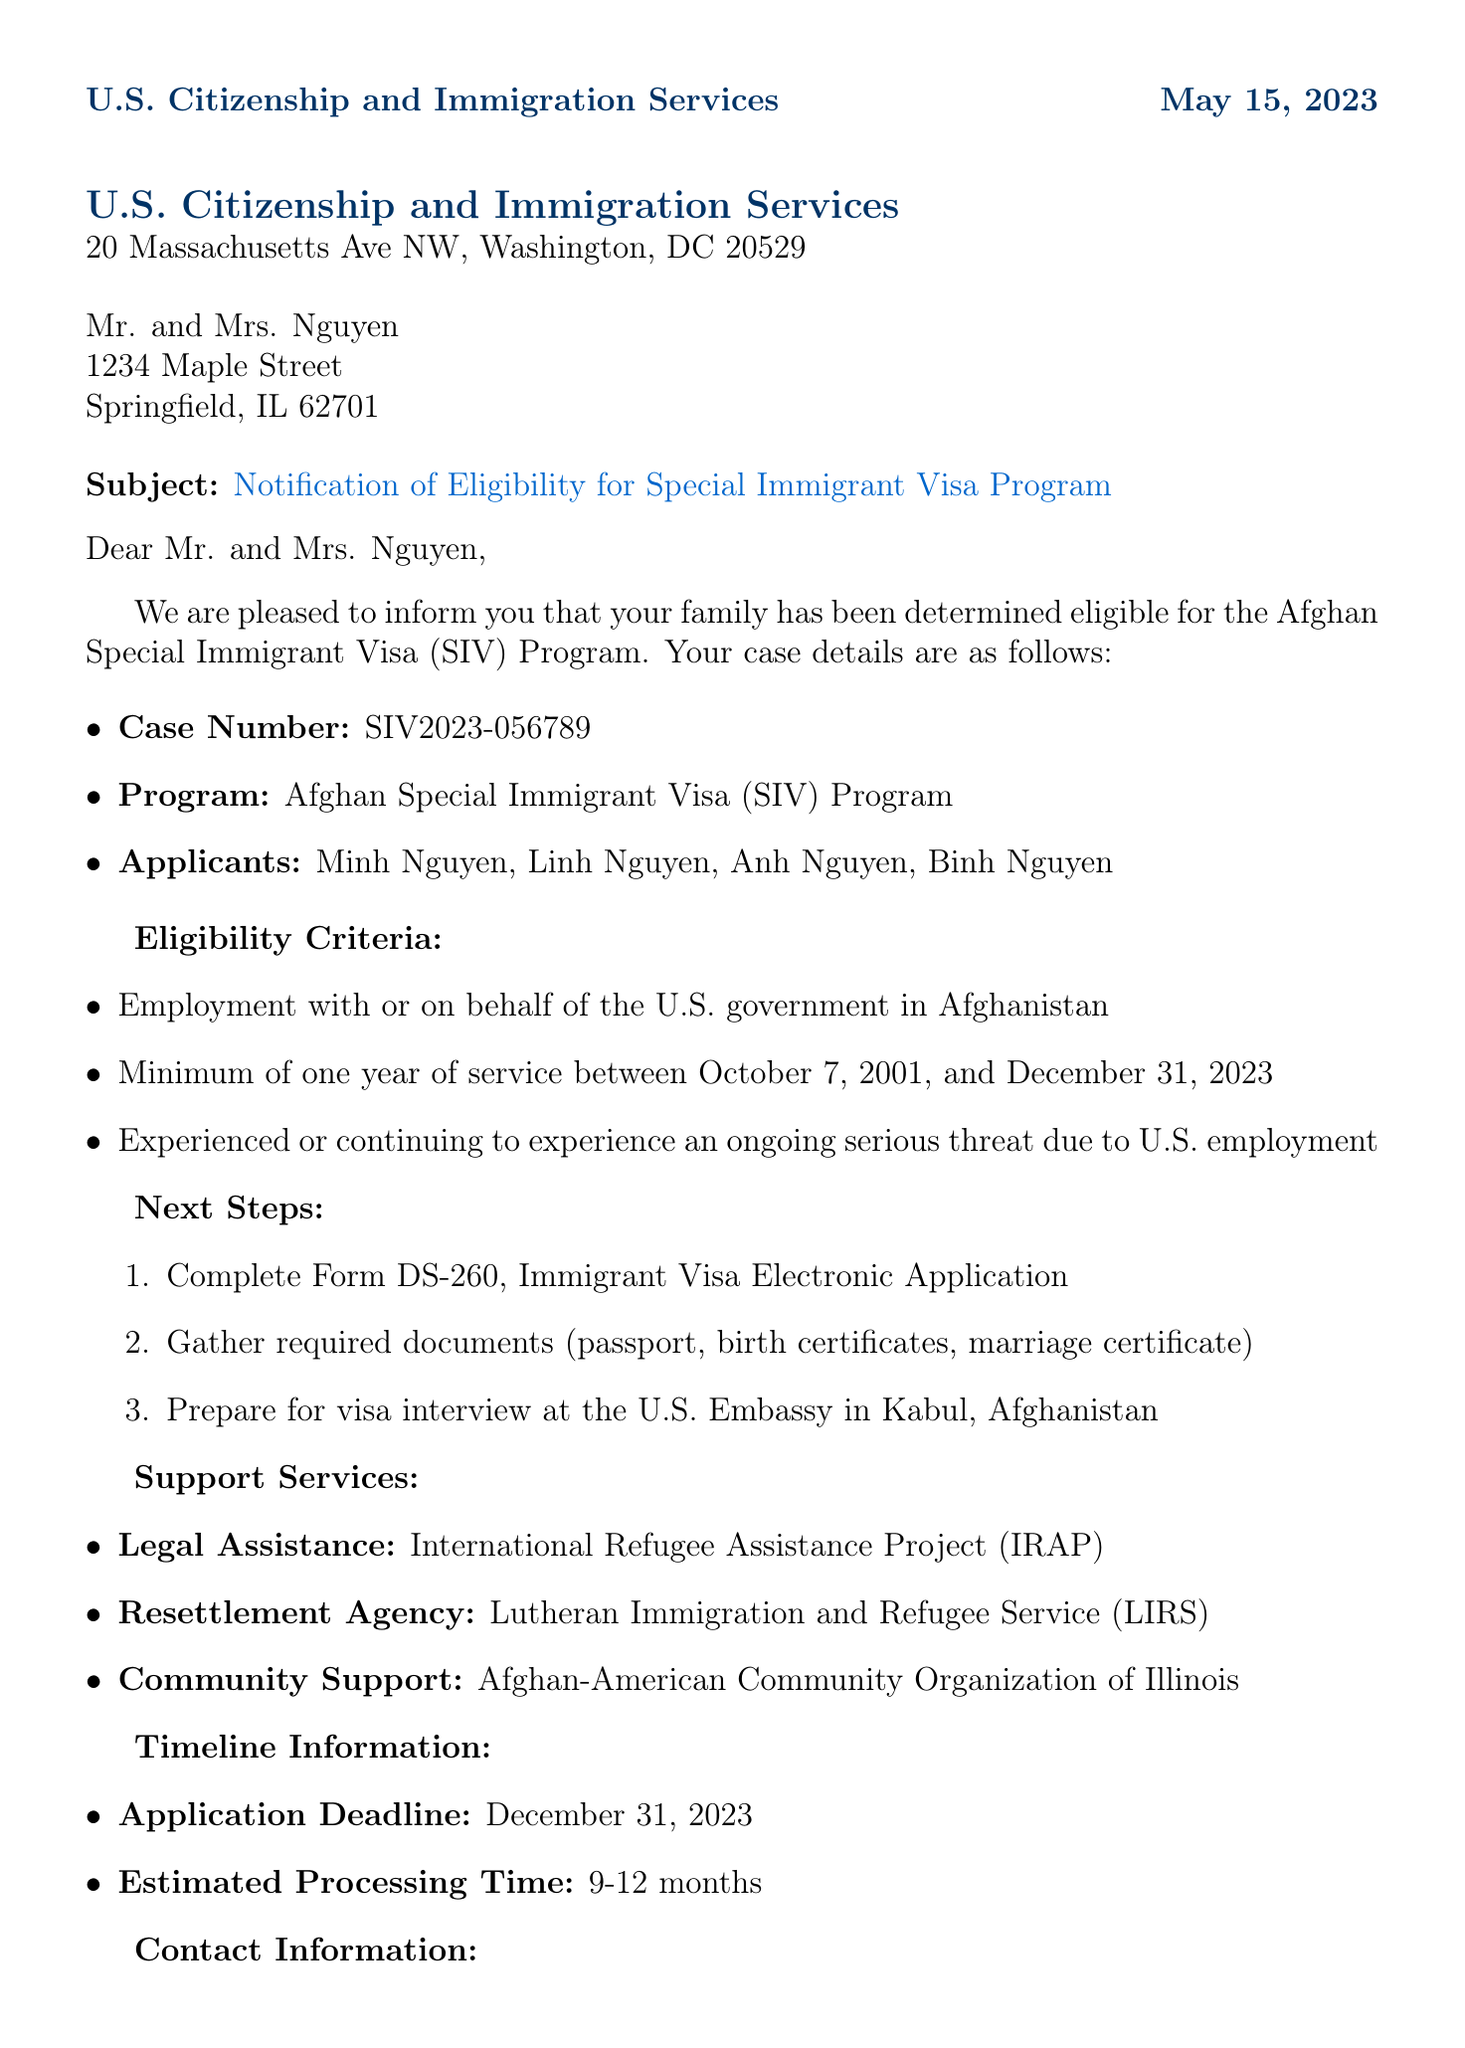what is the date of the letter? The date of the letter is listed in the header section of the document.
Answer: May 15, 2023 who is the recipient of the letter? The recipient information provides the names of the individuals to whom the letter is addressed.
Answer: Mr. and Mrs. Nguyen what is the case number? The case number is a specific identifier for the family's application mentioned in the document.
Answer: SIV2023-056789 what is the application deadline? The deadline for submitting the application is explicitly mentioned towards the end of the letter.
Answer: December 31, 2023 how many applicants are listed? The number of applicants can be counted from the list provided in the case details.
Answer: 4 what is the estimated processing time? The document lays out the anticipated duration for processing the visa application.
Answer: 9-12 months which program is this letter regarding? The specific program for which eligibility is being notified is mentioned in the subject line and case details.
Answer: Afghan Special Immigrant Visa (SIV) Program what is one of the community support services mentioned? The letter provides specific community support services available to the family.
Answer: Afghan-American Community Organization of Illinois what is the phone number for contact information? The document includes a designated phone number for inquiries related to the case.
Answer: +1 (800) 375-5283 